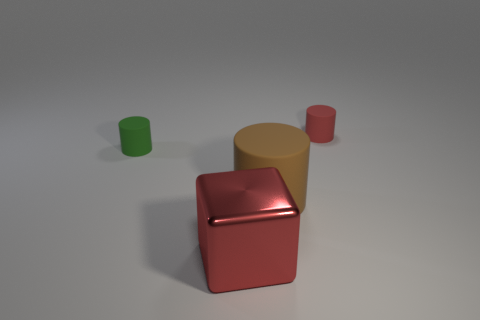How could the size of these objects influence their potential functionality? The small size of the objects, particularly the green and red ones, could limit their functionality to small storage, decorative, or even educational purposes in teaching about geometry and color. The larger tan cylinder could conceivably function as a container or prop, given its more substantial size relative to the others. 